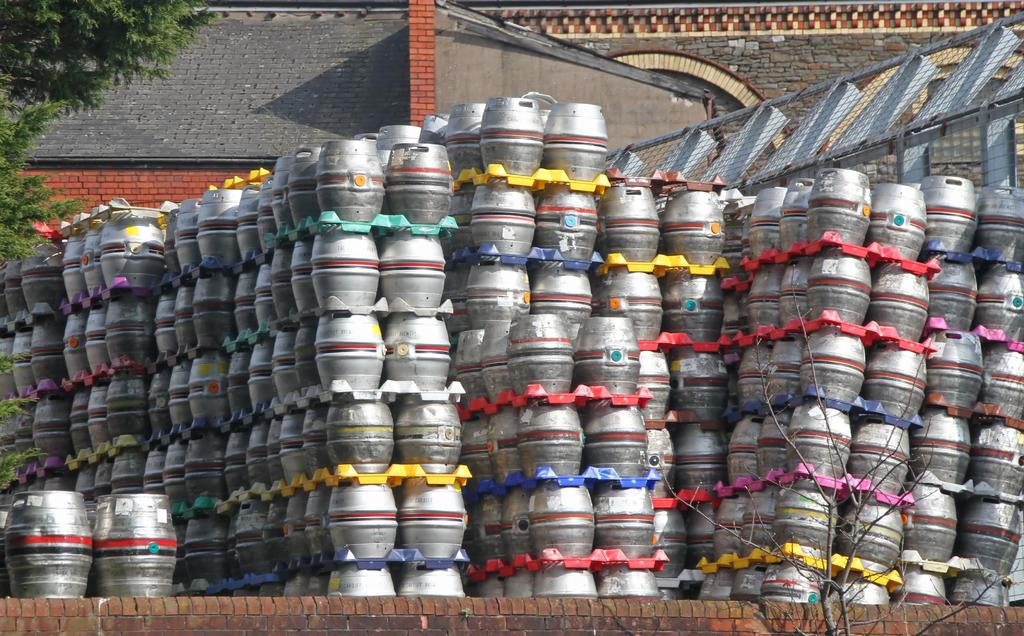What objects are arranged in rows and columns in the image? There are containers in the image that are arranged in rows and columns. What can be seen in the background of the image? There is a tree and buildings visible in the image. What grade of wood is used to make the beds in the image? There are no beds present in the image, so it is not possible to determine the grade of wood used. 